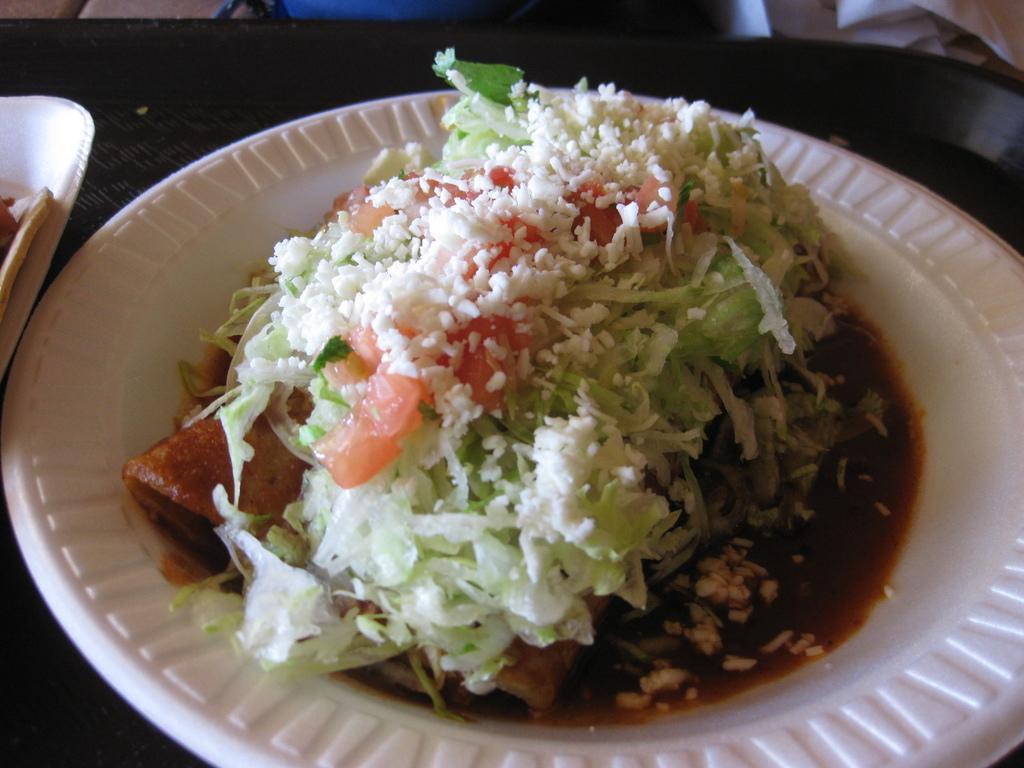Describe this image in one or two sentences. In this image we can see two plates containing food are placed on the table. 